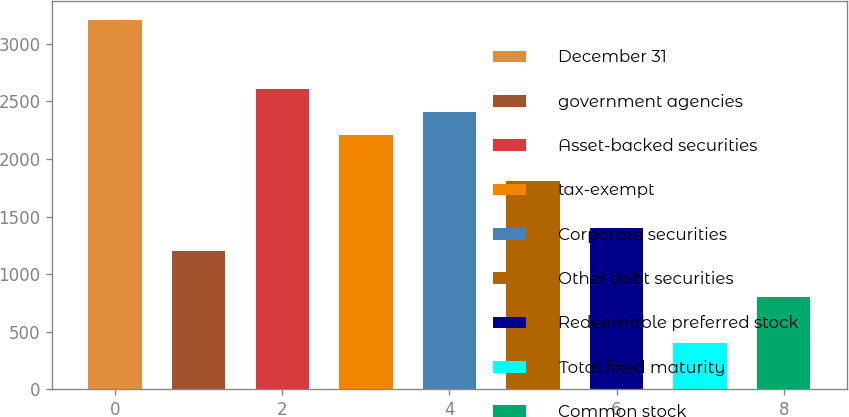Convert chart to OTSL. <chart><loc_0><loc_0><loc_500><loc_500><bar_chart><fcel>December 31<fcel>government agencies<fcel>Asset-backed securities<fcel>tax-exempt<fcel>Corporate securities<fcel>Other debt securities<fcel>Redeemable preferred stock<fcel>Total fixed maturity<fcel>Common stock<nl><fcel>3211.14<fcel>1204.24<fcel>2609.07<fcel>2207.69<fcel>2408.38<fcel>1806.31<fcel>1404.93<fcel>401.48<fcel>802.86<nl></chart> 